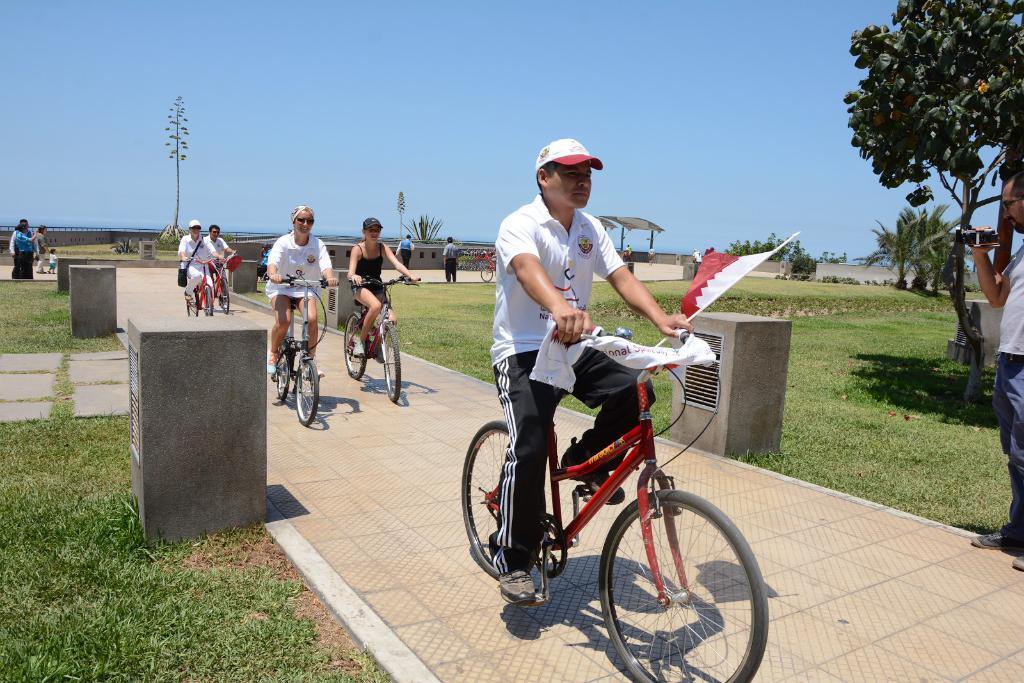How would you summarize this image in a sentence or two? This is completely an outdoor picture. On the background we can see a blue sky, trees and we can see few persons walking here. This is fresh green grass. At the right side of the picture we can see one man holding a camera in his hand and recording. We can see few persons riding a bicycle. Here this is a flag. 